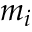<formula> <loc_0><loc_0><loc_500><loc_500>m _ { i }</formula> 